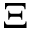<formula> <loc_0><loc_0><loc_500><loc_500>\Xi</formula> 